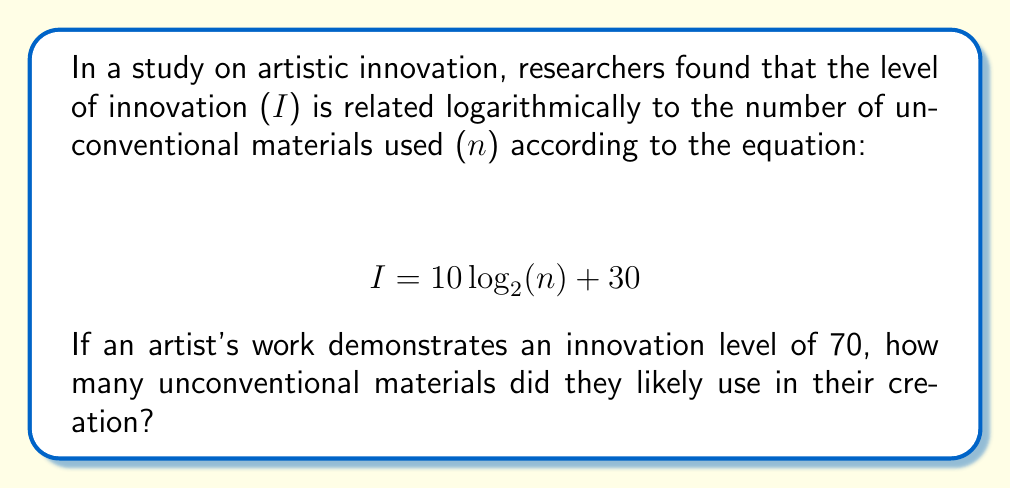Could you help me with this problem? To solve this problem, we need to work backwards from the given innovation level to find the number of unconventional materials. Let's approach this step-by-step:

1) We're given the equation: $I = 10 \log_2(n) + 30$

2) We know that $I = 70$, so we can substitute this:

   $70 = 10 \log_2(n) + 30$

3) First, let's subtract 30 from both sides:

   $40 = 10 \log_2(n)$

4) Now, divide both sides by 10:

   $4 = \log_2(n)$

5) To solve for $n$, we need to apply the inverse function of $\log_2$, which is $2^x$:

   $2^4 = 2^{\log_2(n)}$

6) The right side simplifies to just $n$, so we have:

   $2^4 = n$

7) Calculate $2^4$:

   $16 = n$

Therefore, the artist likely used 16 unconventional materials in their creation.
Answer: 16 unconventional materials 